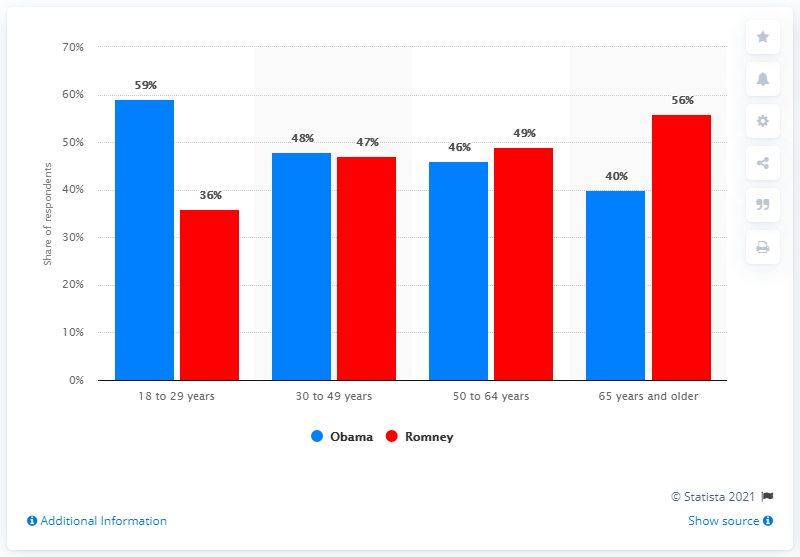Give some essential details in this illustration. The highest percentage in the red bar is 56%. The average voter support for President Obama was 48.25%. 